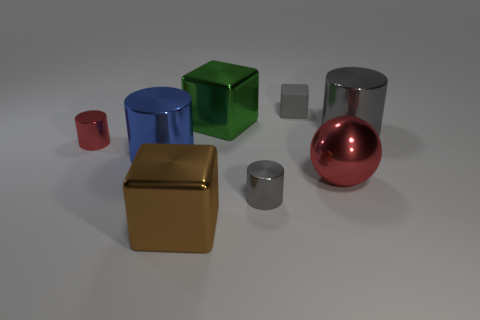What objects in the image have reflective surfaces? In the image, the objects with reflective surfaces include the blue cylinder, the silver cylinder, and the large red sphere. These items exhibit shiny surfaces that reflect the environment and light, indicating they are most likely made from materials like metal or polished plastic. 